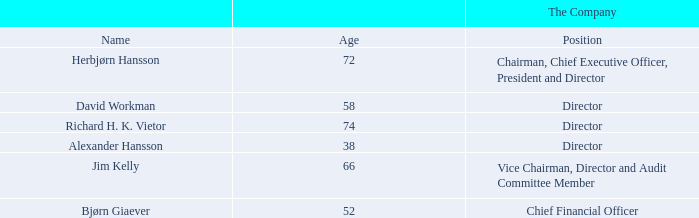ITEM 6. DIRECTORS, SENIOR MANAGEMENT AND EMPLOYEES
A. Directors and Senior Management
Set forth below are the names and positions of our directors of the Company and senior management of the Company. The directors of the Company are elected annually, and each elected director holds office until a successor is elected. Officers are elected from time to time by vote of the Board and holds office until a successor is elected. Set forth below are the names and positions of our directors of the Company and senior management of the Company. The directors of the Company are elected annually, and each elected director holds office until a successor is elected. Officers are elected from time to time by vote of the Board and holds office until a successor is elected.
Certain biographical information with respect to each director and senior management of the Company listed above is set forth below. On March 6, 2020, Andreas Ove Ugland, a director and Vice Chairman of the Company and our Audit Committee Chairman, passed. Mr. Ugland had been a valued member of our Board of Directors since 1997.
Herbjørn Hansson earned his M.B.A. at the Norwegian School of Economics and Business Administration and attended Harvard Business School. In 1974 he was employed by the Norwegian Shipowners’ Association. In the period from 1975 to 1980, he was Chief Economist and Research Manager of INTERTANKO, an industry association whose members control about 70% of the world’s independently owned tanker fleet, excluding state owned and oil company fleets. During the 1980s, he was Chief Financial Officer of Kosmos/Anders Jahre, at the time one of the largest Norwegian based shipping and industry groups. In 1989, Mr. Hansson founded Ugland Nordic Shipping AS, or UNS, which became one of the world’s largest owners of specialized shuttle tankers. He served as Chairman in the first phase and as Chief Executive Officer as from 1993 to 2001 when UNS, under his management, was sold to Teekay Shipping Corporation, or Teekay, for an enterprise value of $780.0 million. He continued to work with Teekay, and reached the position of Vice Chairman of Teekay Norway AS, until he started working full-time for the Company on September 1, 2004. Mr. Hansson is the founder and has been Chairman and Chief Executive Officer of the Company since its establishment in 1995. He also has been a member of various governing bodies of companies within shipping, insurance, banking, manufacturing, national/international shipping agencies including classification societies and protection and indemnity associations. Mr. Hansson is fluent in Norwegian and English, and has a command of German and French for conversational purposes.
David Workman has been a director of the Company since November 2019. Mr. Workman has served as Hermitage Offshore Services Ltd.’s Class A Director since December 2013. Mr. Workman was Chief Operating Officer and member of the Supervisory Board of Stork Technical Services, or STS, guided, as Chief Executive Officer, the sale of the RBG Offshore Services Group into the STS group in 2011. Mr. Workman has 30 years of broad experience in the offshore sector ranging from drilling operations/field development through production operations and project management. He has worked with a wide variety of exploration and production companies in the sector and has balanced this with exposure to the service sector, working with management companies. As part of his experience with these different companies, he has had extensive exposure to the North Sea market. Mr. Workman graduated from Imperial College London in 1983 with a Masters in Petroleum Engineering and spent his early years as a Drilling/Production Operations Engineer with BP. In 1987 he joined Hamilton Brothers Oil and Gas who were early adopters of floating production systems. In 1993 he joined Kerr McGee as an operations manager for the Tentech 850 designed Gryphon FPSO, the first permanently moored FPSO in the North Sea. In 1996, Mr. Workman established the service company Atlantic Floating Production, which went on to become the management contractor and duty holder on the John Fredriksen owned Northern Producer and on the Petroleum Geo-Services (PGS) owned Banff FPF. In 2003, Mr. Workman was instrumental in founding Tuscan Energy which went on to redevelop the abandoned Argyll Field in the UK Continental Shelf. In 2009, Mr. Workman was appointed as Chief Executive Officer of STS in 2011.
Richard H. K. Vietor has been a director of the Company since July 2007. Mr. Vietor is the Paul Whiton Cherrington Professor of Business Administration where he teaches courses on the regulation of business and the international political economy. He was appointed Professor in 1984. Before coming to Harvard Business School in 1978, Professor Vietor held faculty appointments at Virginia Polytechnic Institute and the University of Missouri. He received a B.A. in economics from Union College in 1967, an M.A. in history from Hofstra University in 1971, and a Ph.D. from the University of Pittsburgh in 1975.
Alexander Hansson has been a director of the Company since November 2019. Mr. Hansson is an investor in various markets globally and has made several successful investments in both listed and privately held companies. Mr. Hansson is the son of the Company’s Chairman and Chief Executive Officer and he has built a network over the last 20 years in the shipping and finance sector. He has operated shipping and trading offices in London and Monaco. He studied at EBS Regents College in London, United Kingdom.
Jim Kelly has been a director of the Company since June 2010. Mr. Kelly has worked for Time Inc., the world’s largest magazine publisher, since 1978. He served as Foreign Editor during the fall of the Soviet Union and the first Gulf War, and was named Deputy Managing Editor in 1996. In 2001, Mr. Kelly became the magazine’s managing editor, and during his tenure the magazine won a record four National Magazine awards. In 2004, Time Magazine received its first EMMA for its contribution to the ABC News Series “Iraq: Where Things Stand.” In late 2006, Mr. Kelly became the managing editor of all of Time Inc., helping supervise the work of more than 2,000 journalists working at 125 titles, including Fortune, Money, Sports Illustrated and People. Since 2009, Mr. Kelly has worked as a consultant at Bloomberg LP and taught at Princeton and Columbia Universities. Jim Kelly was elected as member of our Audit Committee in February 2012. Mr. Kelly was appointed as the Chairman of the Audit Committee upon the passing of Mr. Ugland.
Bjørn Giaever joined the Company as Chief Financial Officer and Secretary on October 16, 2017. Mr. Giaever has over 20 years of experience in the shipping & offshore industry, holding key roles in corporate finance and equity research. He joined the Company from Fearnley Securities AS, where he served as partner and director in the Corporate Finance division. From 2006 to 2010, Mr. Giaever served as a senior corporate advisor in the John Fredriksen group in London. In addition, Mr. Giaever has been a top rated Shipping Analyst at DNB Markets and partner at Inge Steensland AS, specializing in gas and maritime matters. Mr. Giaever holds a BSc in business and economics.
Who are the respective chairman and vice chairman of the company? Herbjørn hansson, jim kelly. Who are the company's directors? David workman, richard h. k. vietor, alexander hansson, herbjørn hansson, jim kelly. Who are the company's Chief Executive Officer and Chief Financial Officer? Herbjørn hansson, bjørn giaever. What is the average age of the company's Chairman and Vice Chairman? (72 + 66)/2 
Answer: 69. What is the average age of the company's Chief Executive Officer and Chief Financial Officer? (72 + 52)/2 
Answer: 62. What is the total age of the company's Chief Executive Officer and Chief Financial Officer? (72 + 52) 
Answer: 124. 